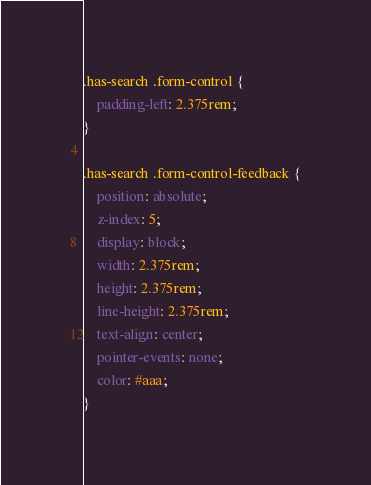<code> <loc_0><loc_0><loc_500><loc_500><_CSS_>.has-search .form-control {
    padding-left: 2.375rem;
}

.has-search .form-control-feedback {
    position: absolute;
    z-index: 5;
    display: block;
    width: 2.375rem;
    height: 2.375rem;
    line-height: 2.375rem;
    text-align: center;
    pointer-events: none;
    color: #aaa;
}</code> 